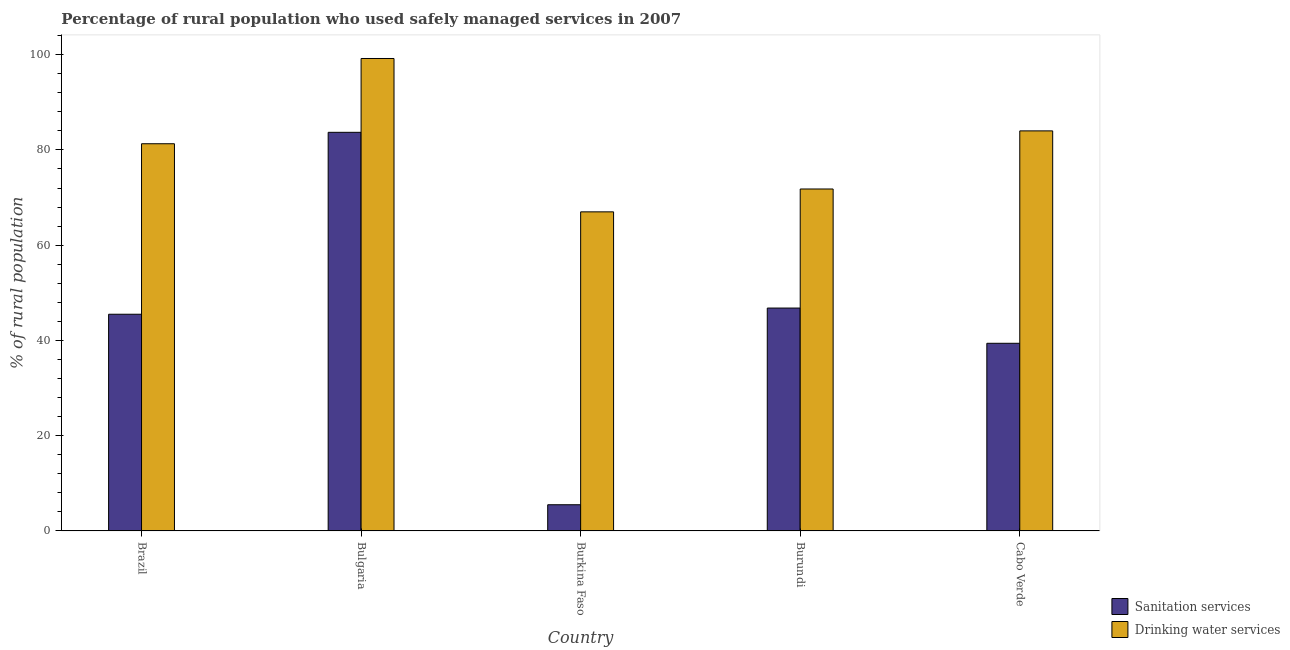How many different coloured bars are there?
Provide a short and direct response. 2. How many groups of bars are there?
Ensure brevity in your answer.  5. Are the number of bars per tick equal to the number of legend labels?
Provide a short and direct response. Yes. Are the number of bars on each tick of the X-axis equal?
Make the answer very short. Yes. How many bars are there on the 3rd tick from the left?
Make the answer very short. 2. How many bars are there on the 2nd tick from the right?
Offer a terse response. 2. What is the label of the 1st group of bars from the left?
Keep it short and to the point. Brazil. In how many cases, is the number of bars for a given country not equal to the number of legend labels?
Keep it short and to the point. 0. What is the percentage of rural population who used drinking water services in Cabo Verde?
Provide a succinct answer. 84. Across all countries, what is the maximum percentage of rural population who used sanitation services?
Your response must be concise. 83.7. Across all countries, what is the minimum percentage of rural population who used sanitation services?
Give a very brief answer. 5.5. In which country was the percentage of rural population who used drinking water services maximum?
Your response must be concise. Bulgaria. In which country was the percentage of rural population who used drinking water services minimum?
Your response must be concise. Burkina Faso. What is the total percentage of rural population who used drinking water services in the graph?
Provide a short and direct response. 403.3. What is the difference between the percentage of rural population who used drinking water services in Burkina Faso and that in Burundi?
Provide a succinct answer. -4.8. What is the difference between the percentage of rural population who used drinking water services in Burkina Faso and the percentage of rural population who used sanitation services in Cabo Verde?
Give a very brief answer. 27.6. What is the average percentage of rural population who used drinking water services per country?
Your response must be concise. 80.66. In how many countries, is the percentage of rural population who used sanitation services greater than 20 %?
Your answer should be compact. 4. What is the ratio of the percentage of rural population who used drinking water services in Brazil to that in Burundi?
Provide a succinct answer. 1.13. Is the difference between the percentage of rural population who used sanitation services in Burkina Faso and Burundi greater than the difference between the percentage of rural population who used drinking water services in Burkina Faso and Burundi?
Offer a terse response. No. What is the difference between the highest and the second highest percentage of rural population who used sanitation services?
Your response must be concise. 36.9. What is the difference between the highest and the lowest percentage of rural population who used sanitation services?
Your answer should be very brief. 78.2. Is the sum of the percentage of rural population who used sanitation services in Bulgaria and Burundi greater than the maximum percentage of rural population who used drinking water services across all countries?
Provide a short and direct response. Yes. What does the 2nd bar from the left in Burkina Faso represents?
Offer a very short reply. Drinking water services. What does the 1st bar from the right in Bulgaria represents?
Make the answer very short. Drinking water services. How many bars are there?
Your answer should be compact. 10. Are all the bars in the graph horizontal?
Your response must be concise. No. What is the difference between two consecutive major ticks on the Y-axis?
Provide a short and direct response. 20. How many legend labels are there?
Offer a terse response. 2. How are the legend labels stacked?
Give a very brief answer. Vertical. What is the title of the graph?
Offer a terse response. Percentage of rural population who used safely managed services in 2007. What is the label or title of the X-axis?
Provide a succinct answer. Country. What is the label or title of the Y-axis?
Offer a very short reply. % of rural population. What is the % of rural population of Sanitation services in Brazil?
Your response must be concise. 45.5. What is the % of rural population in Drinking water services in Brazil?
Provide a succinct answer. 81.3. What is the % of rural population of Sanitation services in Bulgaria?
Offer a terse response. 83.7. What is the % of rural population in Drinking water services in Bulgaria?
Keep it short and to the point. 99.2. What is the % of rural population of Sanitation services in Burkina Faso?
Your answer should be very brief. 5.5. What is the % of rural population in Sanitation services in Burundi?
Give a very brief answer. 46.8. What is the % of rural population in Drinking water services in Burundi?
Your response must be concise. 71.8. What is the % of rural population of Sanitation services in Cabo Verde?
Offer a terse response. 39.4. What is the % of rural population in Drinking water services in Cabo Verde?
Offer a very short reply. 84. Across all countries, what is the maximum % of rural population of Sanitation services?
Provide a succinct answer. 83.7. Across all countries, what is the maximum % of rural population in Drinking water services?
Make the answer very short. 99.2. Across all countries, what is the minimum % of rural population of Drinking water services?
Ensure brevity in your answer.  67. What is the total % of rural population of Sanitation services in the graph?
Your answer should be compact. 220.9. What is the total % of rural population of Drinking water services in the graph?
Give a very brief answer. 403.3. What is the difference between the % of rural population in Sanitation services in Brazil and that in Bulgaria?
Provide a short and direct response. -38.2. What is the difference between the % of rural population in Drinking water services in Brazil and that in Bulgaria?
Make the answer very short. -17.9. What is the difference between the % of rural population in Sanitation services in Brazil and that in Burundi?
Offer a terse response. -1.3. What is the difference between the % of rural population in Sanitation services in Brazil and that in Cabo Verde?
Provide a succinct answer. 6.1. What is the difference between the % of rural population in Sanitation services in Bulgaria and that in Burkina Faso?
Keep it short and to the point. 78.2. What is the difference between the % of rural population of Drinking water services in Bulgaria and that in Burkina Faso?
Your answer should be very brief. 32.2. What is the difference between the % of rural population in Sanitation services in Bulgaria and that in Burundi?
Your response must be concise. 36.9. What is the difference between the % of rural population of Drinking water services in Bulgaria and that in Burundi?
Give a very brief answer. 27.4. What is the difference between the % of rural population in Sanitation services in Bulgaria and that in Cabo Verde?
Ensure brevity in your answer.  44.3. What is the difference between the % of rural population of Drinking water services in Bulgaria and that in Cabo Verde?
Your response must be concise. 15.2. What is the difference between the % of rural population of Sanitation services in Burkina Faso and that in Burundi?
Keep it short and to the point. -41.3. What is the difference between the % of rural population in Drinking water services in Burkina Faso and that in Burundi?
Ensure brevity in your answer.  -4.8. What is the difference between the % of rural population of Sanitation services in Burkina Faso and that in Cabo Verde?
Your answer should be compact. -33.9. What is the difference between the % of rural population of Sanitation services in Burundi and that in Cabo Verde?
Give a very brief answer. 7.4. What is the difference between the % of rural population of Sanitation services in Brazil and the % of rural population of Drinking water services in Bulgaria?
Provide a short and direct response. -53.7. What is the difference between the % of rural population in Sanitation services in Brazil and the % of rural population in Drinking water services in Burkina Faso?
Your answer should be very brief. -21.5. What is the difference between the % of rural population of Sanitation services in Brazil and the % of rural population of Drinking water services in Burundi?
Provide a succinct answer. -26.3. What is the difference between the % of rural population in Sanitation services in Brazil and the % of rural population in Drinking water services in Cabo Verde?
Give a very brief answer. -38.5. What is the difference between the % of rural population of Sanitation services in Bulgaria and the % of rural population of Drinking water services in Burkina Faso?
Your response must be concise. 16.7. What is the difference between the % of rural population in Sanitation services in Bulgaria and the % of rural population in Drinking water services in Cabo Verde?
Make the answer very short. -0.3. What is the difference between the % of rural population of Sanitation services in Burkina Faso and the % of rural population of Drinking water services in Burundi?
Provide a short and direct response. -66.3. What is the difference between the % of rural population in Sanitation services in Burkina Faso and the % of rural population in Drinking water services in Cabo Verde?
Make the answer very short. -78.5. What is the difference between the % of rural population in Sanitation services in Burundi and the % of rural population in Drinking water services in Cabo Verde?
Make the answer very short. -37.2. What is the average % of rural population in Sanitation services per country?
Make the answer very short. 44.18. What is the average % of rural population in Drinking water services per country?
Your answer should be very brief. 80.66. What is the difference between the % of rural population in Sanitation services and % of rural population in Drinking water services in Brazil?
Give a very brief answer. -35.8. What is the difference between the % of rural population of Sanitation services and % of rural population of Drinking water services in Bulgaria?
Make the answer very short. -15.5. What is the difference between the % of rural population in Sanitation services and % of rural population in Drinking water services in Burkina Faso?
Your answer should be very brief. -61.5. What is the difference between the % of rural population of Sanitation services and % of rural population of Drinking water services in Burundi?
Ensure brevity in your answer.  -25. What is the difference between the % of rural population of Sanitation services and % of rural population of Drinking water services in Cabo Verde?
Offer a terse response. -44.6. What is the ratio of the % of rural population in Sanitation services in Brazil to that in Bulgaria?
Provide a succinct answer. 0.54. What is the ratio of the % of rural population of Drinking water services in Brazil to that in Bulgaria?
Ensure brevity in your answer.  0.82. What is the ratio of the % of rural population in Sanitation services in Brazil to that in Burkina Faso?
Your response must be concise. 8.27. What is the ratio of the % of rural population in Drinking water services in Brazil to that in Burkina Faso?
Make the answer very short. 1.21. What is the ratio of the % of rural population of Sanitation services in Brazil to that in Burundi?
Provide a short and direct response. 0.97. What is the ratio of the % of rural population in Drinking water services in Brazil to that in Burundi?
Your answer should be compact. 1.13. What is the ratio of the % of rural population of Sanitation services in Brazil to that in Cabo Verde?
Give a very brief answer. 1.15. What is the ratio of the % of rural population in Drinking water services in Brazil to that in Cabo Verde?
Offer a terse response. 0.97. What is the ratio of the % of rural population in Sanitation services in Bulgaria to that in Burkina Faso?
Keep it short and to the point. 15.22. What is the ratio of the % of rural population in Drinking water services in Bulgaria to that in Burkina Faso?
Provide a short and direct response. 1.48. What is the ratio of the % of rural population in Sanitation services in Bulgaria to that in Burundi?
Offer a terse response. 1.79. What is the ratio of the % of rural population in Drinking water services in Bulgaria to that in Burundi?
Your answer should be compact. 1.38. What is the ratio of the % of rural population in Sanitation services in Bulgaria to that in Cabo Verde?
Your answer should be compact. 2.12. What is the ratio of the % of rural population of Drinking water services in Bulgaria to that in Cabo Verde?
Provide a short and direct response. 1.18. What is the ratio of the % of rural population of Sanitation services in Burkina Faso to that in Burundi?
Keep it short and to the point. 0.12. What is the ratio of the % of rural population in Drinking water services in Burkina Faso to that in Burundi?
Your answer should be compact. 0.93. What is the ratio of the % of rural population in Sanitation services in Burkina Faso to that in Cabo Verde?
Your answer should be very brief. 0.14. What is the ratio of the % of rural population of Drinking water services in Burkina Faso to that in Cabo Verde?
Provide a short and direct response. 0.8. What is the ratio of the % of rural population in Sanitation services in Burundi to that in Cabo Verde?
Give a very brief answer. 1.19. What is the ratio of the % of rural population of Drinking water services in Burundi to that in Cabo Verde?
Ensure brevity in your answer.  0.85. What is the difference between the highest and the second highest % of rural population in Sanitation services?
Provide a succinct answer. 36.9. What is the difference between the highest and the second highest % of rural population of Drinking water services?
Offer a very short reply. 15.2. What is the difference between the highest and the lowest % of rural population in Sanitation services?
Your response must be concise. 78.2. What is the difference between the highest and the lowest % of rural population in Drinking water services?
Offer a very short reply. 32.2. 